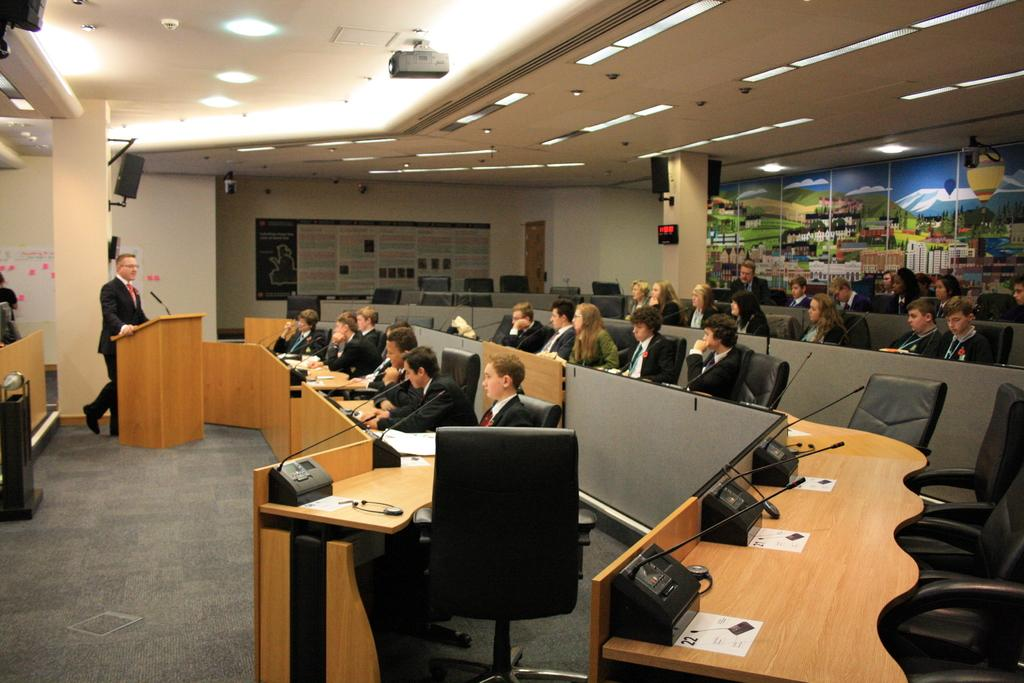What is happening in the image involving a group of people? There is a group of people in the image, and they are sitting on chairs. What can be seen on the table in the image? There are papers on the table in the image. What is visible in the background of the image? There is a wall visible in the image. What type of bubble can be seen floating in the image? There is no bubble present in the image. 